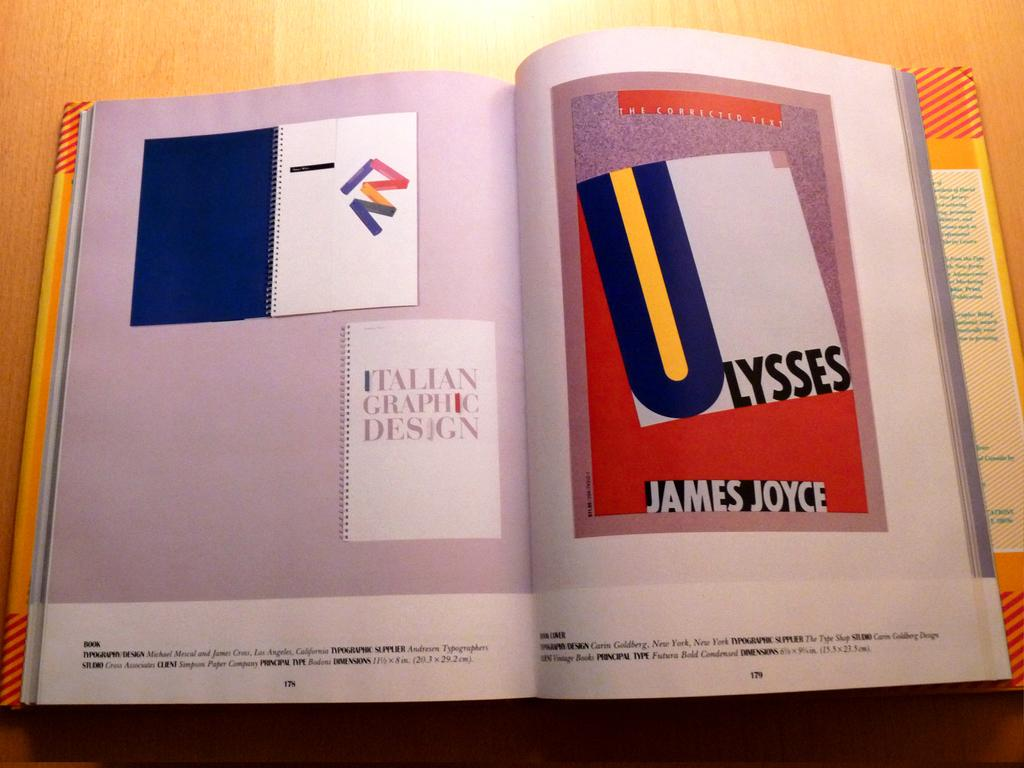<image>
Describe the image concisely. An open book with James Joyce on the right page 